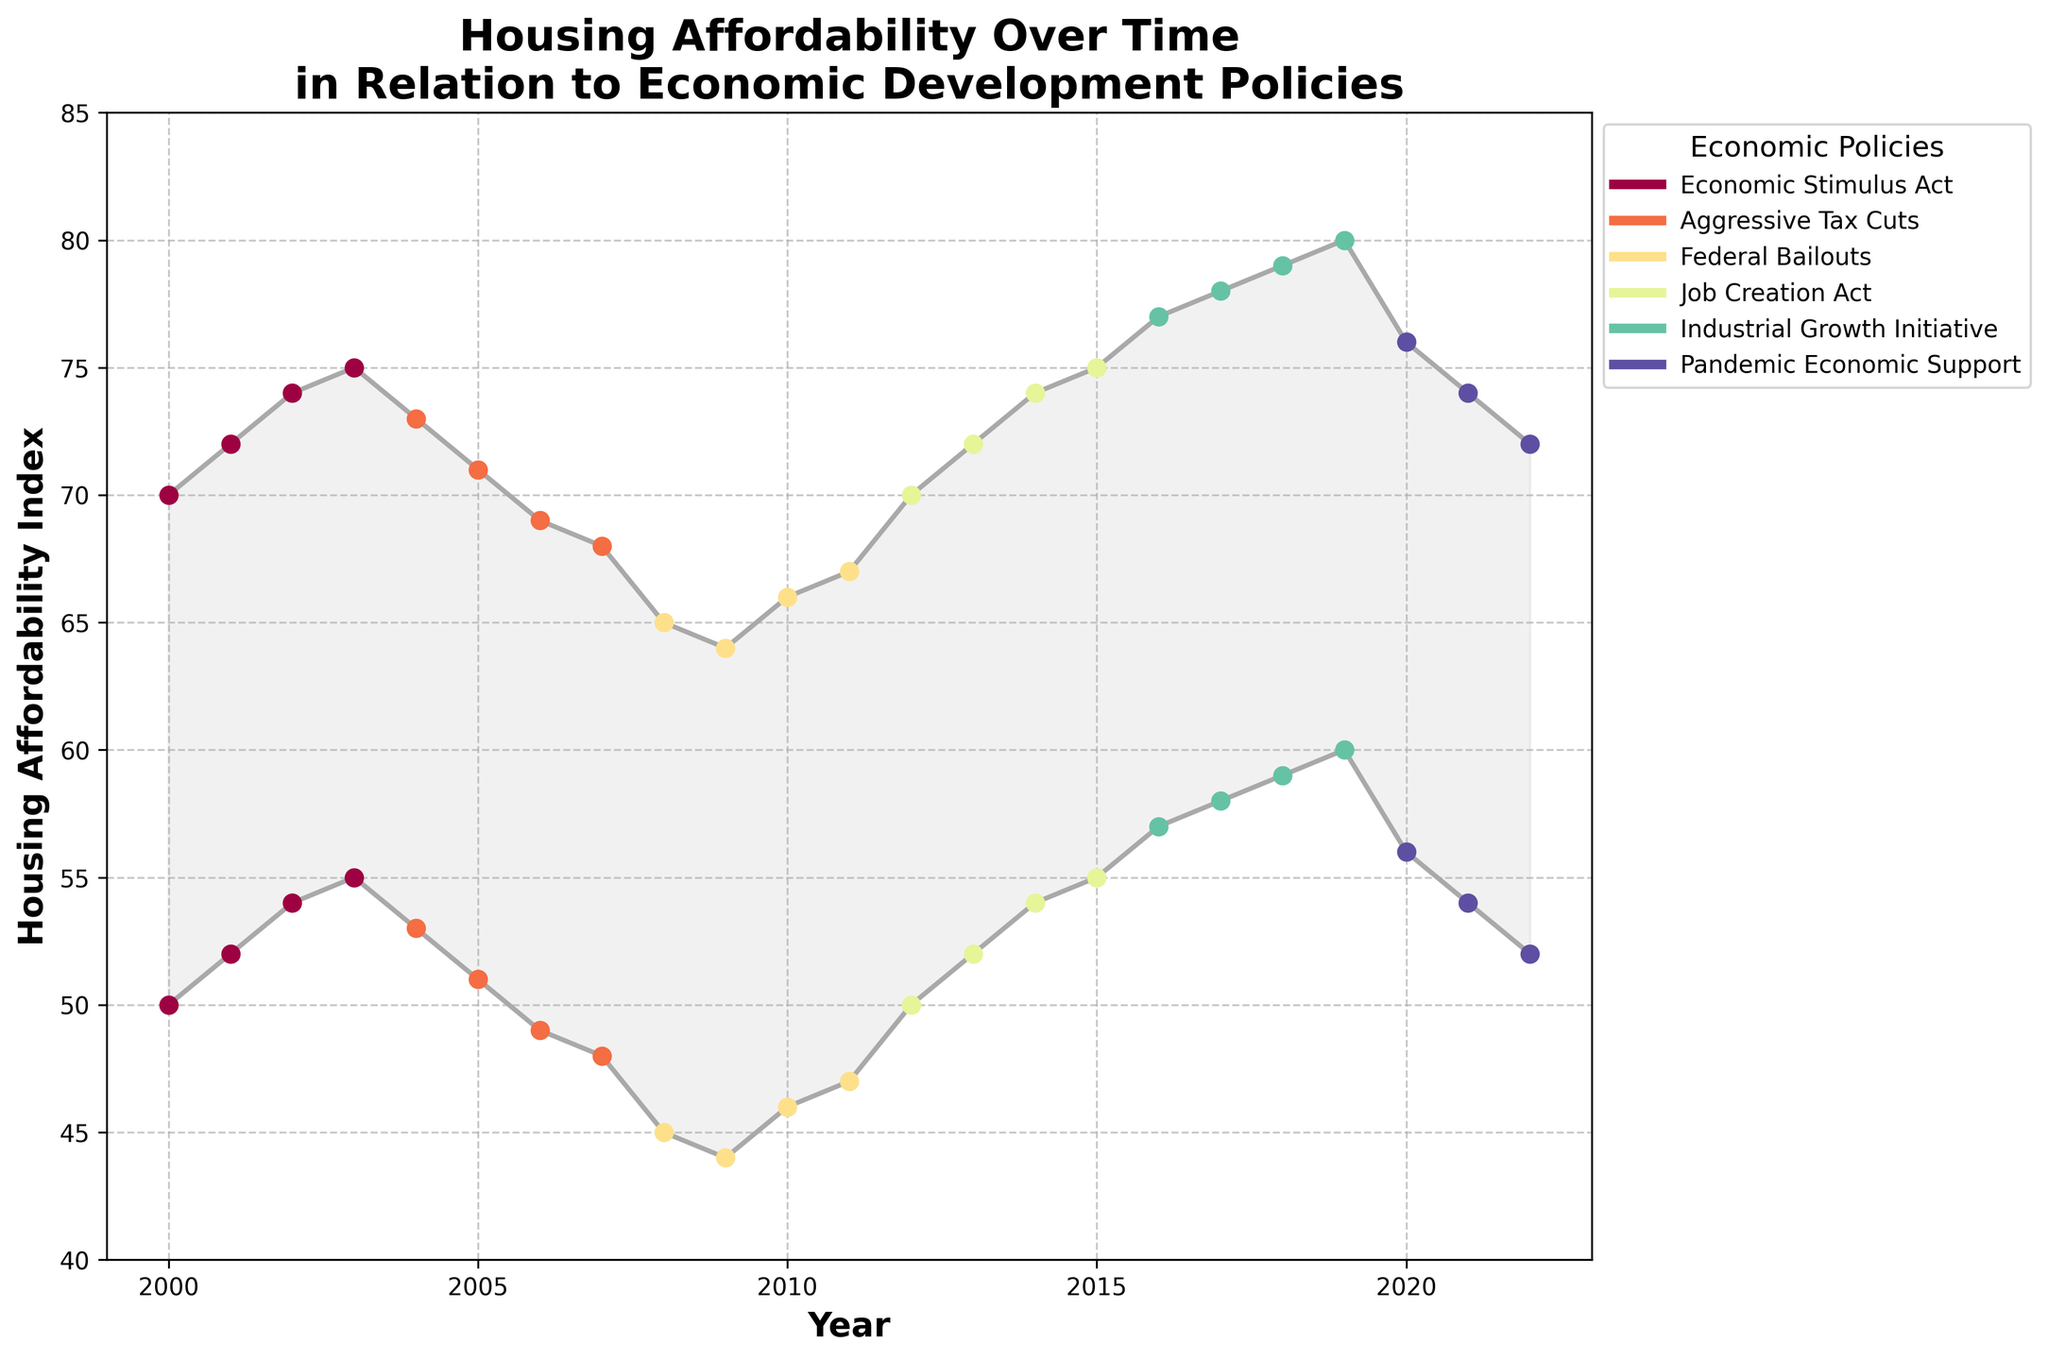What is the title of the chart? The title is usually positioned at the top of the chart and is displayed prominently. Here, it reads 'Housing Affordability Over Time in Relation to Economic Development Policies'.
Answer: Housing Affordability Over Time in Relation to Economic Development Policies What is the minimum housing affordability index shown on the chart? The y-axis displays the Housing Affordability Index, and the lowest value shown on the chart is located towards the bottom of the y-axis, which starts at 40.
Answer: 40 During which years was the 'Aggressive Tax Cuts' policy in place? By looking at the scatter plot points' colors corresponding to each policy in the legend, we can identify that 'Aggressive Tax Cuts' were in place from 2004 to 2007.
Answer: 2004 to 2007 Which year experienced the highest maximum affordability index? Observing the maximum affordability indices (the upper bound of the shaded area), 2019 has the highest value, which is 80, corresponding to the 'Industrial Growth Initiative' policy.
Answer: 2019 How does the housing affordability index trend during the 'Federal Bailouts' policy period? Observing the range of indices and the policy timeline, from 2008 to 2011, there is a slight increase in both the minimum and maximum affordability indices starting from 45-65 up to 47-67.
Answer: Slight increase How many different economic policies are represented in the data? The legend lists each unique policy represented by different colors. Counting these, we find there are six different policies.
Answer: Six What was the change in the minimum affordability index from 2007 to 2008? The minimum affordability index decreased from 48 in 2007 (Aggressive Tax Cuts) to 45 in 2008 (Federal Bailouts). This is a drop of 3 points.
Answer: Decrease by 3 points Which policy had the most consistent affordability index over its period? By identifying the policy periods and checking the fluctuation range, the 'Job Creation Act' (2012-2015) has a steady increase in both minimum and maximum indices without fluctuations.
Answer: Job Creation Act Compare the housing affordability during 'Pandemic Economic Support' with 'Industrial Growth Initiative'. 'Pandemic Economic Support' (2020-2022) shows a decrease in both indices from 56-76 to 52-72, whereas 'Industrial Growth Initiative' (2016-2019) shows a steady increase from 57-77 to 60-80.
Answer: 'Industrial Growth Initiative' saw improvement, 'Pandemic Economic Support' saw decline What is the general trend of the affordability index over the entire 2000-2022 period? By looking at the overall trend, both the minimum and maximum affordability indices show a general increase from the early 2000s (50-70) towards 60-80 around 2019, followed by a slight decline towards the end.
Answer: General increase followed by slight decline 